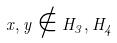Convert formula to latex. <formula><loc_0><loc_0><loc_500><loc_500>x , y \notin H _ { 3 } , H _ { 4 }</formula> 